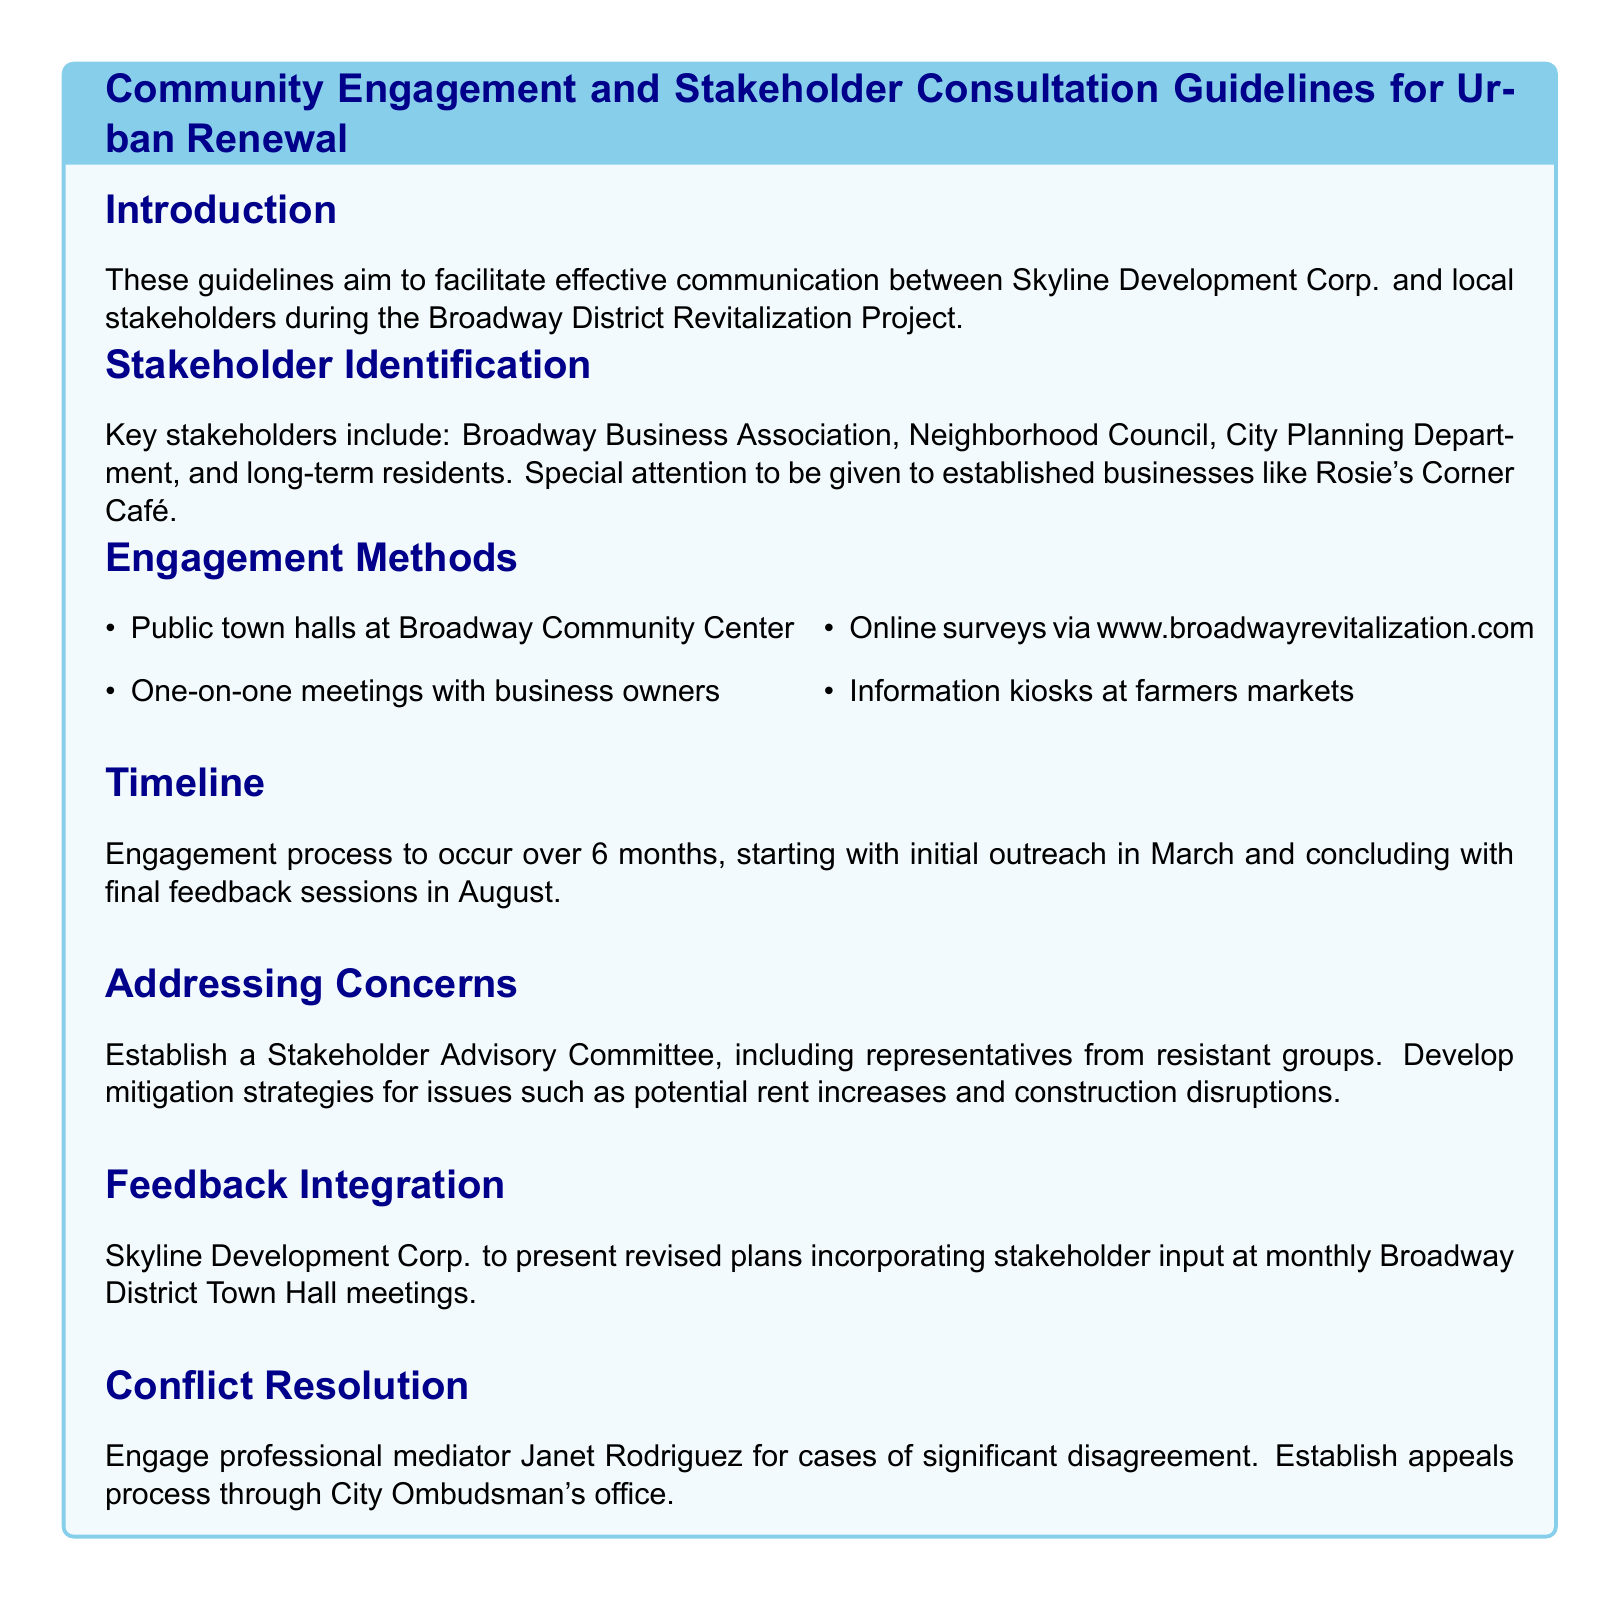What is the title of the document? The title is usually stated prominently at the beginning of the document and indicates the main subject matter.
Answer: Community Engagement and Stakeholder Consultation Guidelines for Urban Renewal Who are the key stakeholders mentioned? The document lists specific groups that are considered important for the engagement process, mentioning their direct names.
Answer: Broadway Business Association, Neighborhood Council, City Planning Department, long-term residents What is the timeline for the engagement process? This refers to the specific period during which stakeholder engagement activities are planned to occur, as stated in the document.
Answer: 6 months What engagement method includes community input? This specifically points to the type of engagement method that allows for public participation and feedback, as outlined in the document.
Answer: Public town halls What role does Janet Rodriguez play in the conflict resolution process? This question looks for the specific title or function of an individual mentioned in the document relative to managing disagreements among stakeholders.
Answer: Professional mediator Which established business is highlighted for special attention? The document emphasizes a particular business for stakeholder engagement, which reflects its significance in the community context.
Answer: Rosie's Corner Café What is the purpose of the Stakeholder Advisory Committee? This requirement reflects the committee’s role as described in the document concerning participation and inclusiveness in the urban renewal process.
Answer: Address concerns How will stakeholder feedback be presented? This question points to the method described for communicating consolidated input from stakeholders back to the community.
Answer: Monthly Broadway District Town Hall meetings 